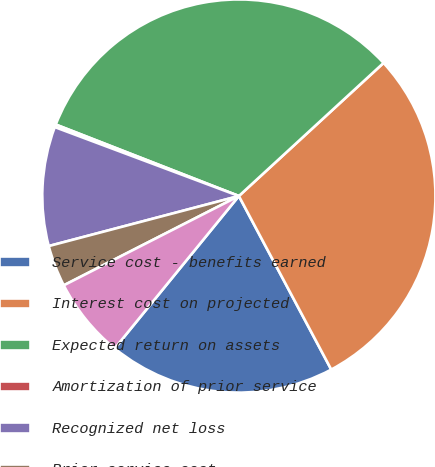Convert chart. <chart><loc_0><loc_0><loc_500><loc_500><pie_chart><fcel>Service cost - benefits earned<fcel>Interest cost on projected<fcel>Expected return on assets<fcel>Amortization of prior service<fcel>Recognized net loss<fcel>Prior service cost<fcel>Net loss<nl><fcel>18.67%<fcel>29.05%<fcel>32.24%<fcel>0.22%<fcel>9.8%<fcel>3.41%<fcel>6.61%<nl></chart> 